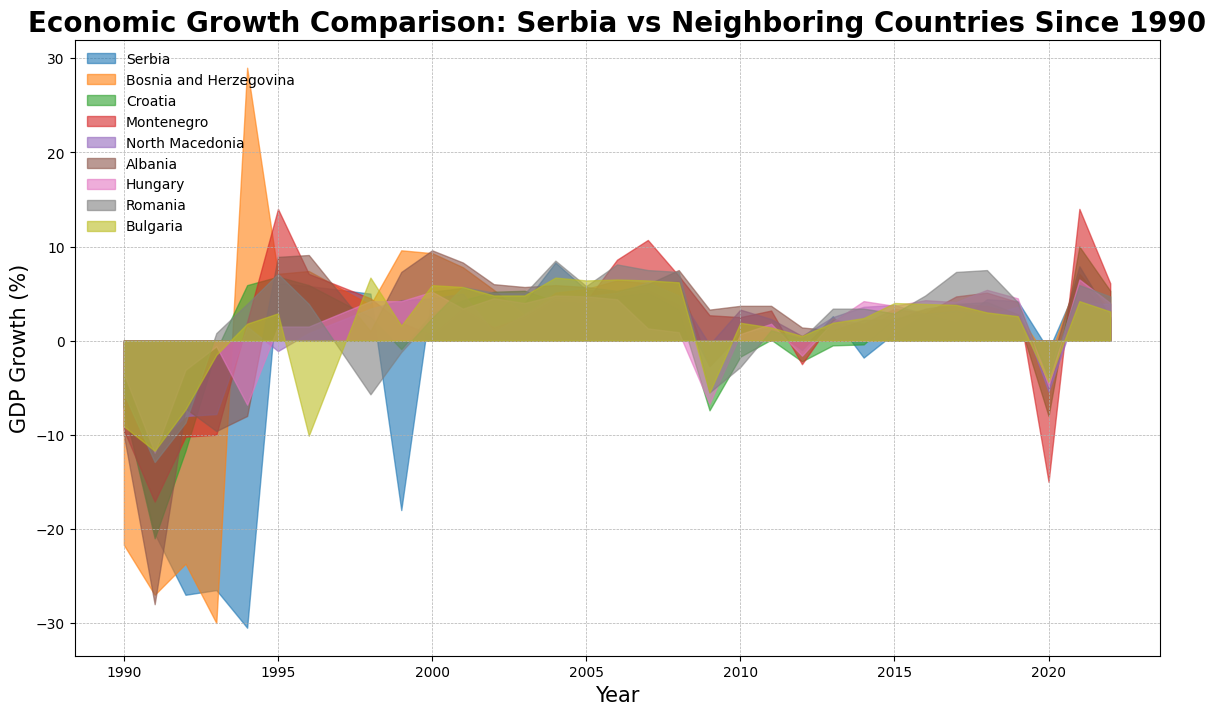What is the overall trend of economic growth in Serbia from 1990 to 2022? Look at the area representing Serbia's economic growth on the chart from left to right. Observe the general direction of the plot lines.
Answer: Overall improving trend with fluctuations Which country had a sharper economic downturn in 1991, Serbia or Bosnia and Herzegovina? Compare the depths of the areas for Serbia and Bosnia and Herzegovina in 1991. Bosnia and Herzegovina's downturn appears to be deeper.
Answer: Bosnia and Herzegovina Which country showed the highest economic growth in 2021? Identify the peak point for each country in 2021 and compare their heights. Croatia has the highest growth.
Answer: Croatia In which year did Serbia experience its worst economic decline, and what was the approximate GDP growth rate? Look for the lowest point in the area representing Serbia's economic growth. The lowest point appears around the early 1990s, specifically in 1994.
Answer: 1994, -30% How does the economic recovery after 2000 compare between Serbia and Croatia? After 2000, examine the upward trends in both the areas representing Serbia and Croatia. Compare the slopes and heights of the areas from 2000 onwards for both countries. Croatia seems to recover faster initially, but Serbia shows consistent growth.
Answer: Croatia shows faster initial recovery, but Serbia has consistent growth Between 1995 and 2000, which countries show a consistent positive GDP growth? Inspect the time period from 1995 to 2000 and identify which countries have areas above the horizontal axis (indicating positive GDP growth) consistently. Countries like Serbia, Bosnia and Herzegovina, and Albania show consistent growth.
Answer: Serbia, Bosnia and Herzegovina, Albania What colors are used to represent Serbia and Croatia in the plot? Identify the color used in the areas representing Serbia and Croatia by mapping the colors to the labels in the legend. Serbia is in blue and Croatia is in green.
Answer: Serbia: blue, Croatia: green Which two countries have the most similar economic growth patterns since 2010? Compare the shapes and trends of the areas for each country from 2010 onwards. Romania and Bulgaria have similar patterns.
Answer: Romania and Bulgaria In what year did Serbia experience a significant economic growth improvement, and what was the approximate percentage? Look for the year when the area representing Serbia shows a steep upward trend after a low point. 1995 shows a notable positive spike.
Answer: 1995, approximately 6% Who exhibited better economic stability, Montenegro or North Macedonia, in the entire period? Observe the fluctuations in the areas representing Montenegro and North Macedonia. North Macedonia's area shows fewer sharp rises and falls compared to Montenegro.
Answer: North Macedonia 